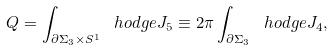Convert formula to latex. <formula><loc_0><loc_0><loc_500><loc_500>Q = \int _ { \partial \Sigma _ { 3 } \times S ^ { 1 } } \ h o d g e { J } _ { 5 } \equiv 2 \pi \int _ { \partial \Sigma _ { 3 } } \ h o d g e { J } _ { 4 } ,</formula> 